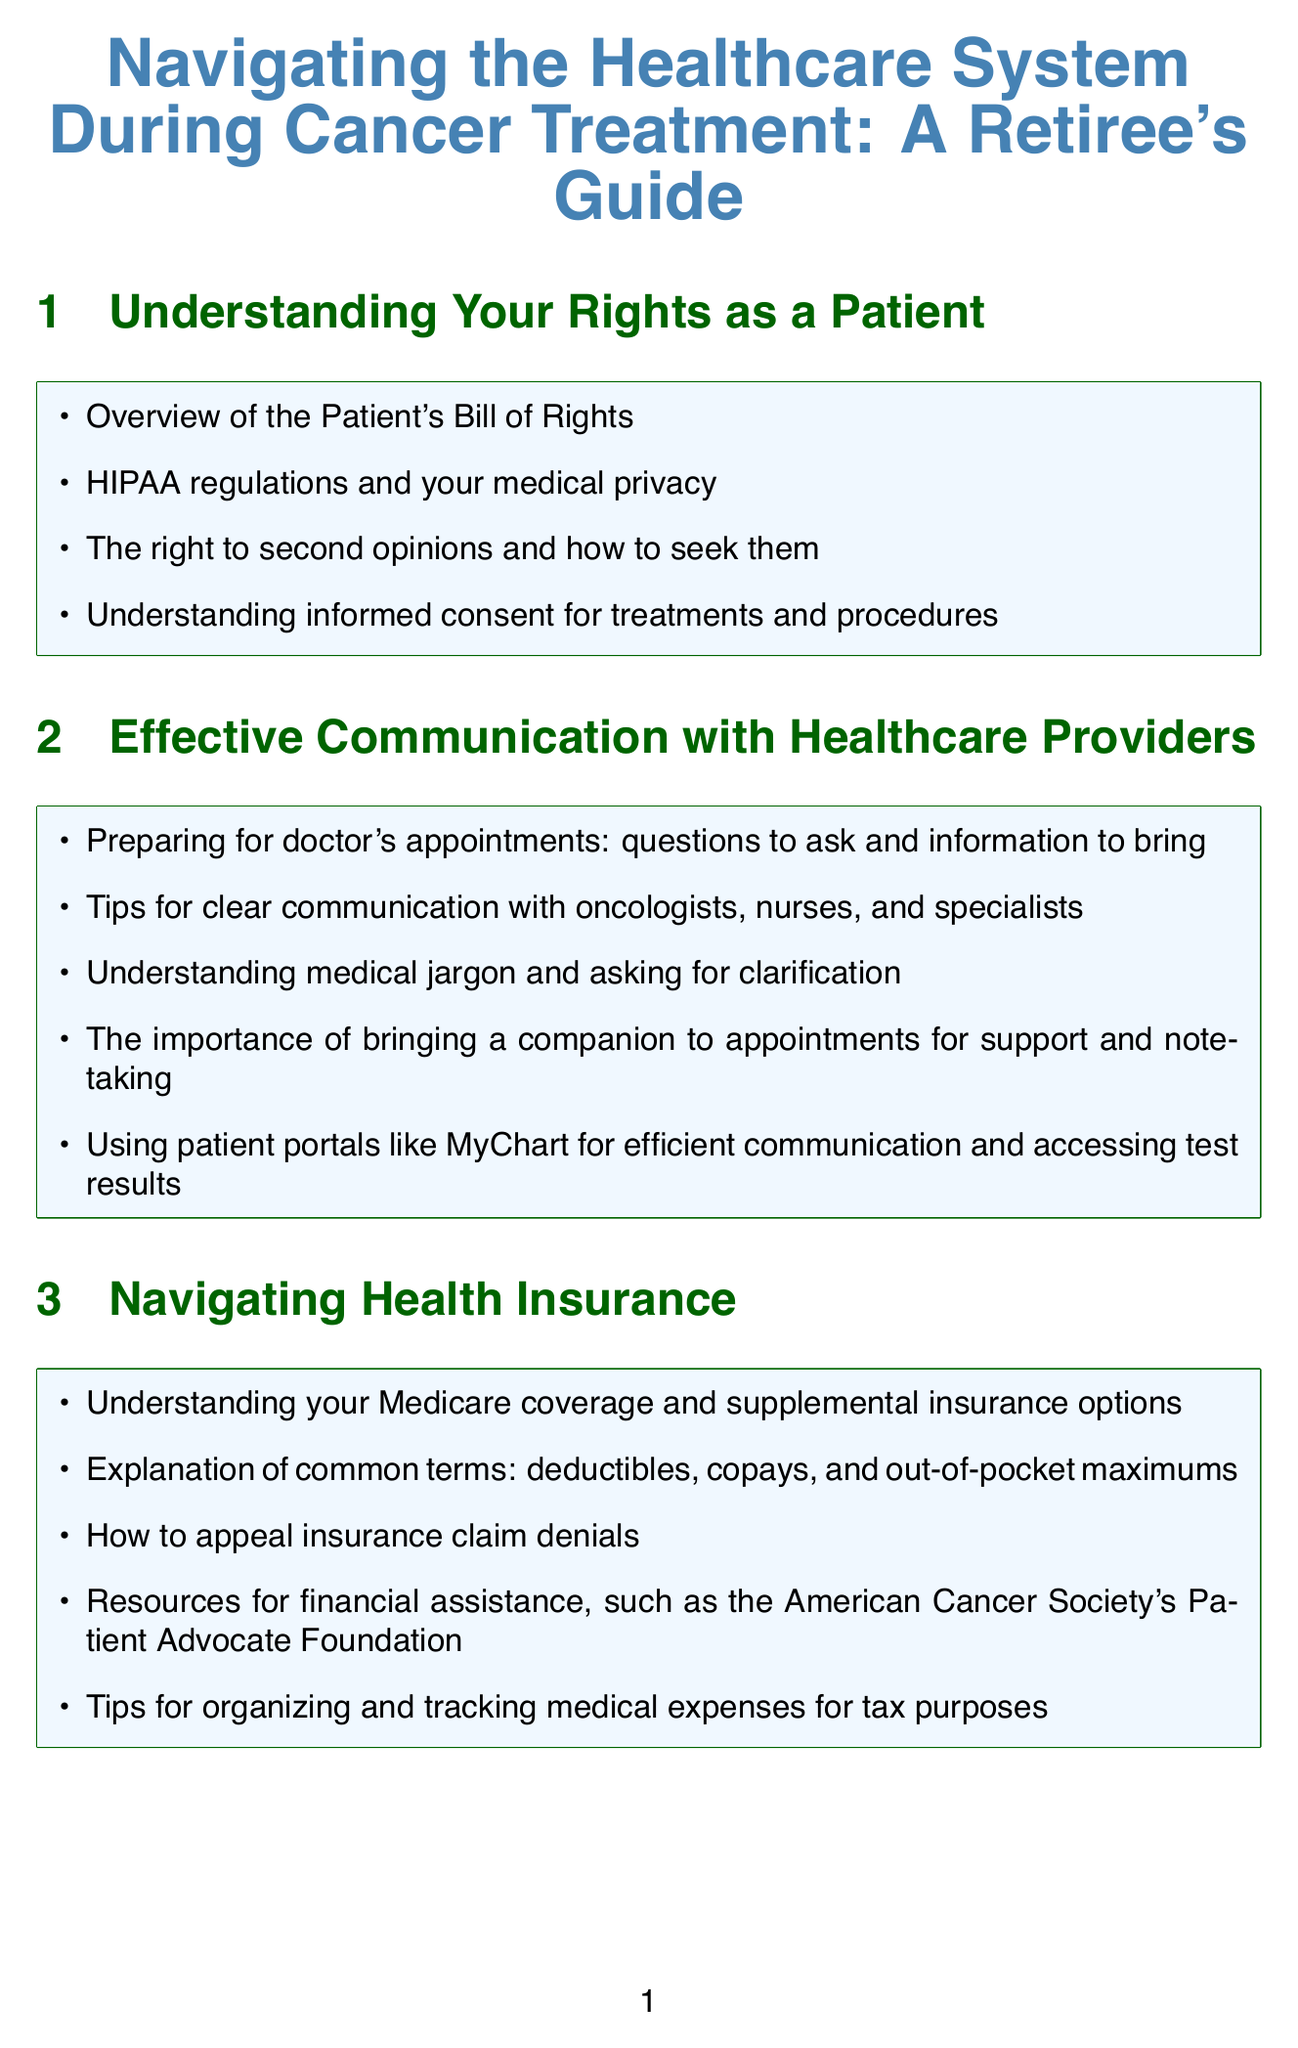What is the title of the guide? The title is the main heading of the document that conveys its primary focus on healthcare navigation during cancer treatment.
Answer: Navigating the Healthcare System During Cancer Treatment: A Retiree's Guide How many sections are there in the document? The number of sections can be counted from the structure of the document, listing all the main headings.
Answer: 10 What are HIPAA regulations concerned with? The content mentions HIPAA regulations as related to privacy and patient's rights, specifying medical privacy aspects.
Answer: Medical privacy What role does a patient navigator play? The document mentions a patient navigator in context with coordinating care and helping patients manage their treatment journey.
Answer: Coordinate care Which organization provides resources for financial assistance? This organization is specifically highlighted in the section about navigating health insurance as a source of aid for patients.
Answer: American Cancer Society's Patient Advocate Foundation What should you bring to doctor's appointments according to the document? The content notes this as a part of preparing for appointments and achieving effective communication with healthcare providers.
Answer: Questions to ask and information to bring What is a key benefit of using patient portals like MyChart? The document explains that these portals facilitate communication and help in accessing test results efficiently.
Answer: Efficient communication When should one seek a second opinion? The content suggests scenarios in which patients might need to seek a second opinion regarding their treatment or care.
Answer: Change healthcare providers What is palliative care's main focus? This is defined in the section discussing end-of-life care and emphasizes the goal of alleviating symptoms rather than curing the illness.
Answer: Symptom management 